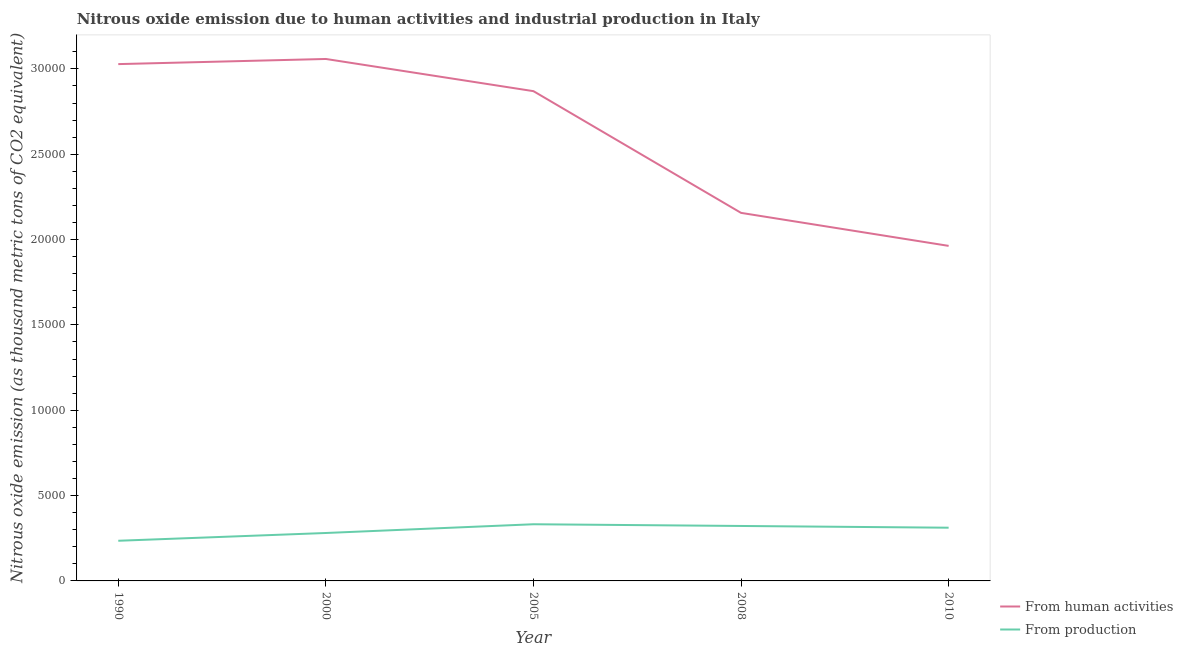How many different coloured lines are there?
Offer a terse response. 2. Is the number of lines equal to the number of legend labels?
Give a very brief answer. Yes. What is the amount of emissions from human activities in 2008?
Provide a short and direct response. 2.16e+04. Across all years, what is the maximum amount of emissions generated from industries?
Provide a short and direct response. 3320.3. Across all years, what is the minimum amount of emissions generated from industries?
Make the answer very short. 2352.7. What is the total amount of emissions generated from industries in the graph?
Provide a succinct answer. 1.48e+04. What is the difference between the amount of emissions from human activities in 1990 and that in 2000?
Offer a terse response. -301.2. What is the difference between the amount of emissions generated from industries in 1990 and the amount of emissions from human activities in 2000?
Ensure brevity in your answer.  -2.82e+04. What is the average amount of emissions from human activities per year?
Give a very brief answer. 2.62e+04. In the year 2005, what is the difference between the amount of emissions generated from industries and amount of emissions from human activities?
Your answer should be very brief. -2.54e+04. In how many years, is the amount of emissions from human activities greater than 2000 thousand metric tons?
Your answer should be very brief. 5. What is the ratio of the amount of emissions generated from industries in 2008 to that in 2010?
Provide a succinct answer. 1.03. Is the amount of emissions generated from industries in 2005 less than that in 2010?
Offer a terse response. No. What is the difference between the highest and the second highest amount of emissions from human activities?
Offer a very short reply. 301.2. What is the difference between the highest and the lowest amount of emissions generated from industries?
Your answer should be very brief. 967.6. In how many years, is the amount of emissions from human activities greater than the average amount of emissions from human activities taken over all years?
Ensure brevity in your answer.  3. Does the amount of emissions generated from industries monotonically increase over the years?
Provide a short and direct response. No. Is the amount of emissions generated from industries strictly greater than the amount of emissions from human activities over the years?
Your response must be concise. No. What is the difference between two consecutive major ticks on the Y-axis?
Your answer should be compact. 5000. Does the graph contain grids?
Provide a succinct answer. No. Where does the legend appear in the graph?
Offer a very short reply. Bottom right. How are the legend labels stacked?
Offer a very short reply. Vertical. What is the title of the graph?
Provide a succinct answer. Nitrous oxide emission due to human activities and industrial production in Italy. What is the label or title of the Y-axis?
Provide a short and direct response. Nitrous oxide emission (as thousand metric tons of CO2 equivalent). What is the Nitrous oxide emission (as thousand metric tons of CO2 equivalent) in From human activities in 1990?
Keep it short and to the point. 3.03e+04. What is the Nitrous oxide emission (as thousand metric tons of CO2 equivalent) in From production in 1990?
Your answer should be compact. 2352.7. What is the Nitrous oxide emission (as thousand metric tons of CO2 equivalent) of From human activities in 2000?
Ensure brevity in your answer.  3.06e+04. What is the Nitrous oxide emission (as thousand metric tons of CO2 equivalent) of From production in 2000?
Provide a succinct answer. 2808.4. What is the Nitrous oxide emission (as thousand metric tons of CO2 equivalent) of From human activities in 2005?
Provide a short and direct response. 2.87e+04. What is the Nitrous oxide emission (as thousand metric tons of CO2 equivalent) in From production in 2005?
Your answer should be very brief. 3320.3. What is the Nitrous oxide emission (as thousand metric tons of CO2 equivalent) in From human activities in 2008?
Your answer should be very brief. 2.16e+04. What is the Nitrous oxide emission (as thousand metric tons of CO2 equivalent) in From production in 2008?
Your response must be concise. 3219.9. What is the Nitrous oxide emission (as thousand metric tons of CO2 equivalent) of From human activities in 2010?
Give a very brief answer. 1.96e+04. What is the Nitrous oxide emission (as thousand metric tons of CO2 equivalent) of From production in 2010?
Offer a terse response. 3117.9. Across all years, what is the maximum Nitrous oxide emission (as thousand metric tons of CO2 equivalent) of From human activities?
Ensure brevity in your answer.  3.06e+04. Across all years, what is the maximum Nitrous oxide emission (as thousand metric tons of CO2 equivalent) of From production?
Offer a terse response. 3320.3. Across all years, what is the minimum Nitrous oxide emission (as thousand metric tons of CO2 equivalent) in From human activities?
Your answer should be very brief. 1.96e+04. Across all years, what is the minimum Nitrous oxide emission (as thousand metric tons of CO2 equivalent) in From production?
Offer a terse response. 2352.7. What is the total Nitrous oxide emission (as thousand metric tons of CO2 equivalent) of From human activities in the graph?
Provide a short and direct response. 1.31e+05. What is the total Nitrous oxide emission (as thousand metric tons of CO2 equivalent) in From production in the graph?
Offer a very short reply. 1.48e+04. What is the difference between the Nitrous oxide emission (as thousand metric tons of CO2 equivalent) of From human activities in 1990 and that in 2000?
Your answer should be compact. -301.2. What is the difference between the Nitrous oxide emission (as thousand metric tons of CO2 equivalent) of From production in 1990 and that in 2000?
Make the answer very short. -455.7. What is the difference between the Nitrous oxide emission (as thousand metric tons of CO2 equivalent) of From human activities in 1990 and that in 2005?
Offer a terse response. 1584.9. What is the difference between the Nitrous oxide emission (as thousand metric tons of CO2 equivalent) of From production in 1990 and that in 2005?
Offer a very short reply. -967.6. What is the difference between the Nitrous oxide emission (as thousand metric tons of CO2 equivalent) of From human activities in 1990 and that in 2008?
Give a very brief answer. 8717. What is the difference between the Nitrous oxide emission (as thousand metric tons of CO2 equivalent) in From production in 1990 and that in 2008?
Provide a succinct answer. -867.2. What is the difference between the Nitrous oxide emission (as thousand metric tons of CO2 equivalent) of From human activities in 1990 and that in 2010?
Offer a terse response. 1.07e+04. What is the difference between the Nitrous oxide emission (as thousand metric tons of CO2 equivalent) of From production in 1990 and that in 2010?
Your response must be concise. -765.2. What is the difference between the Nitrous oxide emission (as thousand metric tons of CO2 equivalent) of From human activities in 2000 and that in 2005?
Offer a very short reply. 1886.1. What is the difference between the Nitrous oxide emission (as thousand metric tons of CO2 equivalent) in From production in 2000 and that in 2005?
Make the answer very short. -511.9. What is the difference between the Nitrous oxide emission (as thousand metric tons of CO2 equivalent) in From human activities in 2000 and that in 2008?
Your response must be concise. 9018.2. What is the difference between the Nitrous oxide emission (as thousand metric tons of CO2 equivalent) in From production in 2000 and that in 2008?
Your answer should be compact. -411.5. What is the difference between the Nitrous oxide emission (as thousand metric tons of CO2 equivalent) of From human activities in 2000 and that in 2010?
Offer a terse response. 1.10e+04. What is the difference between the Nitrous oxide emission (as thousand metric tons of CO2 equivalent) of From production in 2000 and that in 2010?
Give a very brief answer. -309.5. What is the difference between the Nitrous oxide emission (as thousand metric tons of CO2 equivalent) of From human activities in 2005 and that in 2008?
Make the answer very short. 7132.1. What is the difference between the Nitrous oxide emission (as thousand metric tons of CO2 equivalent) in From production in 2005 and that in 2008?
Keep it short and to the point. 100.4. What is the difference between the Nitrous oxide emission (as thousand metric tons of CO2 equivalent) in From human activities in 2005 and that in 2010?
Keep it short and to the point. 9065.9. What is the difference between the Nitrous oxide emission (as thousand metric tons of CO2 equivalent) in From production in 2005 and that in 2010?
Offer a terse response. 202.4. What is the difference between the Nitrous oxide emission (as thousand metric tons of CO2 equivalent) of From human activities in 2008 and that in 2010?
Keep it short and to the point. 1933.8. What is the difference between the Nitrous oxide emission (as thousand metric tons of CO2 equivalent) of From production in 2008 and that in 2010?
Offer a terse response. 102. What is the difference between the Nitrous oxide emission (as thousand metric tons of CO2 equivalent) of From human activities in 1990 and the Nitrous oxide emission (as thousand metric tons of CO2 equivalent) of From production in 2000?
Your answer should be compact. 2.75e+04. What is the difference between the Nitrous oxide emission (as thousand metric tons of CO2 equivalent) of From human activities in 1990 and the Nitrous oxide emission (as thousand metric tons of CO2 equivalent) of From production in 2005?
Provide a short and direct response. 2.70e+04. What is the difference between the Nitrous oxide emission (as thousand metric tons of CO2 equivalent) of From human activities in 1990 and the Nitrous oxide emission (as thousand metric tons of CO2 equivalent) of From production in 2008?
Your response must be concise. 2.71e+04. What is the difference between the Nitrous oxide emission (as thousand metric tons of CO2 equivalent) in From human activities in 1990 and the Nitrous oxide emission (as thousand metric tons of CO2 equivalent) in From production in 2010?
Provide a succinct answer. 2.72e+04. What is the difference between the Nitrous oxide emission (as thousand metric tons of CO2 equivalent) in From human activities in 2000 and the Nitrous oxide emission (as thousand metric tons of CO2 equivalent) in From production in 2005?
Provide a short and direct response. 2.73e+04. What is the difference between the Nitrous oxide emission (as thousand metric tons of CO2 equivalent) in From human activities in 2000 and the Nitrous oxide emission (as thousand metric tons of CO2 equivalent) in From production in 2008?
Your answer should be very brief. 2.74e+04. What is the difference between the Nitrous oxide emission (as thousand metric tons of CO2 equivalent) of From human activities in 2000 and the Nitrous oxide emission (as thousand metric tons of CO2 equivalent) of From production in 2010?
Your response must be concise. 2.75e+04. What is the difference between the Nitrous oxide emission (as thousand metric tons of CO2 equivalent) of From human activities in 2005 and the Nitrous oxide emission (as thousand metric tons of CO2 equivalent) of From production in 2008?
Ensure brevity in your answer.  2.55e+04. What is the difference between the Nitrous oxide emission (as thousand metric tons of CO2 equivalent) of From human activities in 2005 and the Nitrous oxide emission (as thousand metric tons of CO2 equivalent) of From production in 2010?
Your answer should be compact. 2.56e+04. What is the difference between the Nitrous oxide emission (as thousand metric tons of CO2 equivalent) of From human activities in 2008 and the Nitrous oxide emission (as thousand metric tons of CO2 equivalent) of From production in 2010?
Give a very brief answer. 1.84e+04. What is the average Nitrous oxide emission (as thousand metric tons of CO2 equivalent) in From human activities per year?
Ensure brevity in your answer.  2.62e+04. What is the average Nitrous oxide emission (as thousand metric tons of CO2 equivalent) in From production per year?
Your answer should be very brief. 2963.84. In the year 1990, what is the difference between the Nitrous oxide emission (as thousand metric tons of CO2 equivalent) of From human activities and Nitrous oxide emission (as thousand metric tons of CO2 equivalent) of From production?
Ensure brevity in your answer.  2.79e+04. In the year 2000, what is the difference between the Nitrous oxide emission (as thousand metric tons of CO2 equivalent) of From human activities and Nitrous oxide emission (as thousand metric tons of CO2 equivalent) of From production?
Give a very brief answer. 2.78e+04. In the year 2005, what is the difference between the Nitrous oxide emission (as thousand metric tons of CO2 equivalent) in From human activities and Nitrous oxide emission (as thousand metric tons of CO2 equivalent) in From production?
Provide a short and direct response. 2.54e+04. In the year 2008, what is the difference between the Nitrous oxide emission (as thousand metric tons of CO2 equivalent) of From human activities and Nitrous oxide emission (as thousand metric tons of CO2 equivalent) of From production?
Offer a terse response. 1.83e+04. In the year 2010, what is the difference between the Nitrous oxide emission (as thousand metric tons of CO2 equivalent) in From human activities and Nitrous oxide emission (as thousand metric tons of CO2 equivalent) in From production?
Give a very brief answer. 1.65e+04. What is the ratio of the Nitrous oxide emission (as thousand metric tons of CO2 equivalent) in From human activities in 1990 to that in 2000?
Your answer should be very brief. 0.99. What is the ratio of the Nitrous oxide emission (as thousand metric tons of CO2 equivalent) of From production in 1990 to that in 2000?
Offer a terse response. 0.84. What is the ratio of the Nitrous oxide emission (as thousand metric tons of CO2 equivalent) in From human activities in 1990 to that in 2005?
Ensure brevity in your answer.  1.06. What is the ratio of the Nitrous oxide emission (as thousand metric tons of CO2 equivalent) of From production in 1990 to that in 2005?
Make the answer very short. 0.71. What is the ratio of the Nitrous oxide emission (as thousand metric tons of CO2 equivalent) of From human activities in 1990 to that in 2008?
Your answer should be very brief. 1.4. What is the ratio of the Nitrous oxide emission (as thousand metric tons of CO2 equivalent) of From production in 1990 to that in 2008?
Your answer should be compact. 0.73. What is the ratio of the Nitrous oxide emission (as thousand metric tons of CO2 equivalent) in From human activities in 1990 to that in 2010?
Your answer should be very brief. 1.54. What is the ratio of the Nitrous oxide emission (as thousand metric tons of CO2 equivalent) of From production in 1990 to that in 2010?
Ensure brevity in your answer.  0.75. What is the ratio of the Nitrous oxide emission (as thousand metric tons of CO2 equivalent) in From human activities in 2000 to that in 2005?
Offer a very short reply. 1.07. What is the ratio of the Nitrous oxide emission (as thousand metric tons of CO2 equivalent) of From production in 2000 to that in 2005?
Your answer should be very brief. 0.85. What is the ratio of the Nitrous oxide emission (as thousand metric tons of CO2 equivalent) of From human activities in 2000 to that in 2008?
Your answer should be compact. 1.42. What is the ratio of the Nitrous oxide emission (as thousand metric tons of CO2 equivalent) of From production in 2000 to that in 2008?
Your answer should be very brief. 0.87. What is the ratio of the Nitrous oxide emission (as thousand metric tons of CO2 equivalent) of From human activities in 2000 to that in 2010?
Make the answer very short. 1.56. What is the ratio of the Nitrous oxide emission (as thousand metric tons of CO2 equivalent) of From production in 2000 to that in 2010?
Offer a very short reply. 0.9. What is the ratio of the Nitrous oxide emission (as thousand metric tons of CO2 equivalent) in From human activities in 2005 to that in 2008?
Your response must be concise. 1.33. What is the ratio of the Nitrous oxide emission (as thousand metric tons of CO2 equivalent) of From production in 2005 to that in 2008?
Give a very brief answer. 1.03. What is the ratio of the Nitrous oxide emission (as thousand metric tons of CO2 equivalent) of From human activities in 2005 to that in 2010?
Your answer should be very brief. 1.46. What is the ratio of the Nitrous oxide emission (as thousand metric tons of CO2 equivalent) in From production in 2005 to that in 2010?
Offer a terse response. 1.06. What is the ratio of the Nitrous oxide emission (as thousand metric tons of CO2 equivalent) of From human activities in 2008 to that in 2010?
Keep it short and to the point. 1.1. What is the ratio of the Nitrous oxide emission (as thousand metric tons of CO2 equivalent) of From production in 2008 to that in 2010?
Your answer should be compact. 1.03. What is the difference between the highest and the second highest Nitrous oxide emission (as thousand metric tons of CO2 equivalent) in From human activities?
Provide a succinct answer. 301.2. What is the difference between the highest and the second highest Nitrous oxide emission (as thousand metric tons of CO2 equivalent) in From production?
Keep it short and to the point. 100.4. What is the difference between the highest and the lowest Nitrous oxide emission (as thousand metric tons of CO2 equivalent) in From human activities?
Give a very brief answer. 1.10e+04. What is the difference between the highest and the lowest Nitrous oxide emission (as thousand metric tons of CO2 equivalent) of From production?
Keep it short and to the point. 967.6. 